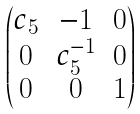Convert formula to latex. <formula><loc_0><loc_0><loc_500><loc_500>\begin{pmatrix} c _ { 5 } & - 1 & 0 \\ 0 & c _ { 5 } ^ { - 1 } & 0 \\ 0 & 0 & 1 \end{pmatrix}</formula> 